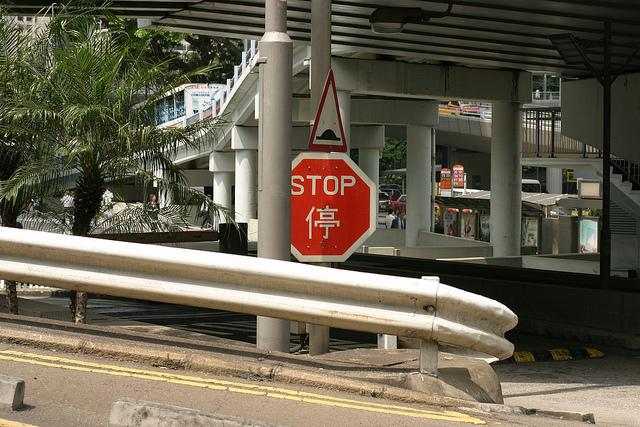What device is used to ensure people stop here?

Choices:
A) camera
B) road spikes
C) speedbump
D) gate speedbump 